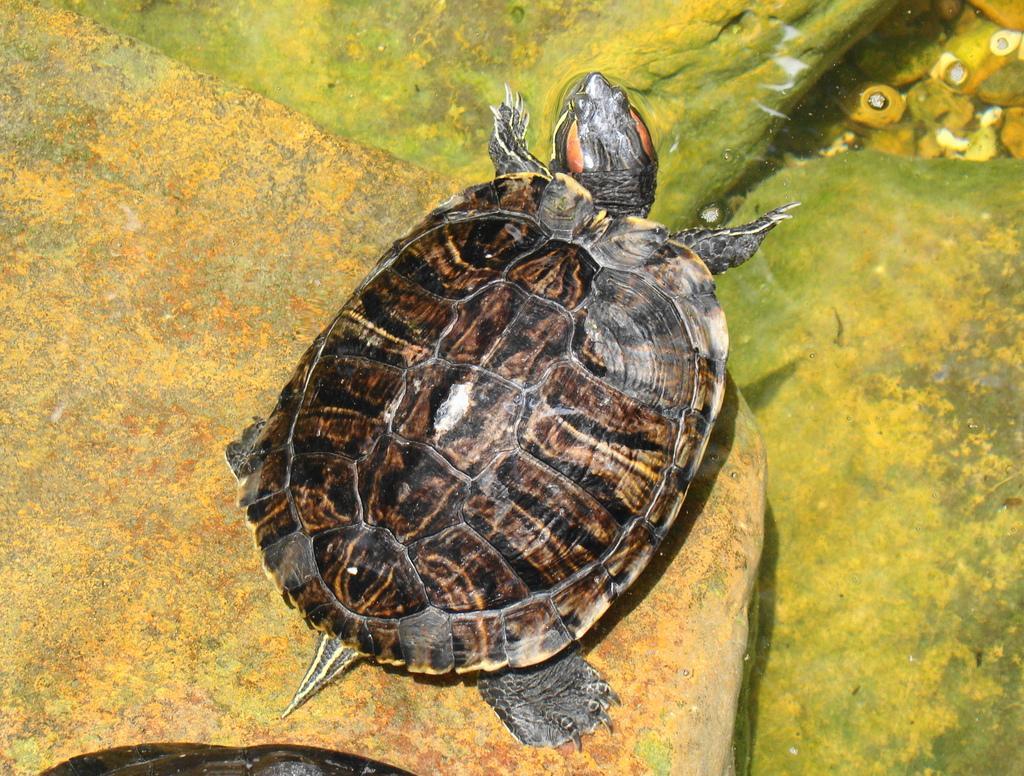Describe this image in one or two sentences. This image consists of a turtle on the rock. At the bottom, there is water. The turtle is in black color. 